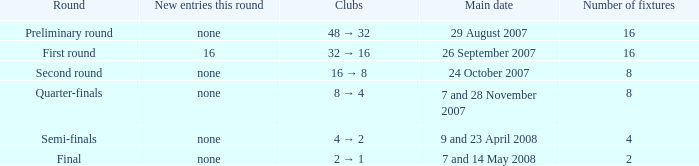What is the sum of Number of fixtures when the rounds shows quarter-finals? 8.0. 